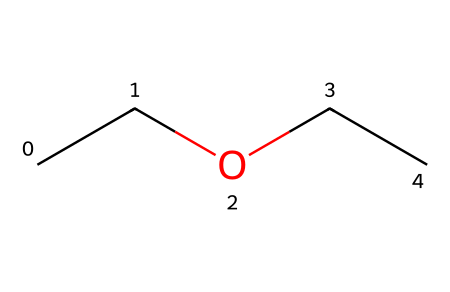What is the IUPAC name of this compound? The SMILES representation "CCOCC" indicates that the main structure contains two ether functional groups (indicated by the oxygen atom between carbon chains). According to IUPAC naming conventions, this compound is termed ethoxyethane.
Answer: ethoxyethane How many carbon atoms are in the chemical? By analyzing the SMILES "CCOCC," we see that there are five carbon atoms represented by the letter "C."
Answer: five What type of functional group is present in this compound? The presence of an oxygen atom (O) between carbon chains indicates that this molecule contains ether functional groups, where oxygen is connected to two alkyl or aryl groups.
Answer: ether How many hydrogen atoms would this compound typically have? The formula for ethers is CnH2n+2O, where n is the number of carbon atoms. For five carbons (n=5), the number of hydrogens is 12; thus, the expected hydrogen count is 12.
Answer: twelve What is the molecular formula of ethoxyethane? Given that this compound has five carbon atoms, twelve hydrogen atoms, and one oxygen atom from the previous calculations and analysis, the molecular formula can be written as C5H12O.
Answer: C5H12O Is this compound soluble in water? As an ether, ethoxyethane tends to be less polar compared to alcohols, generally making it only partially soluble in water. Thus, due to its hydrophobic nature, it has limited solubility.
Answer: partially soluble 